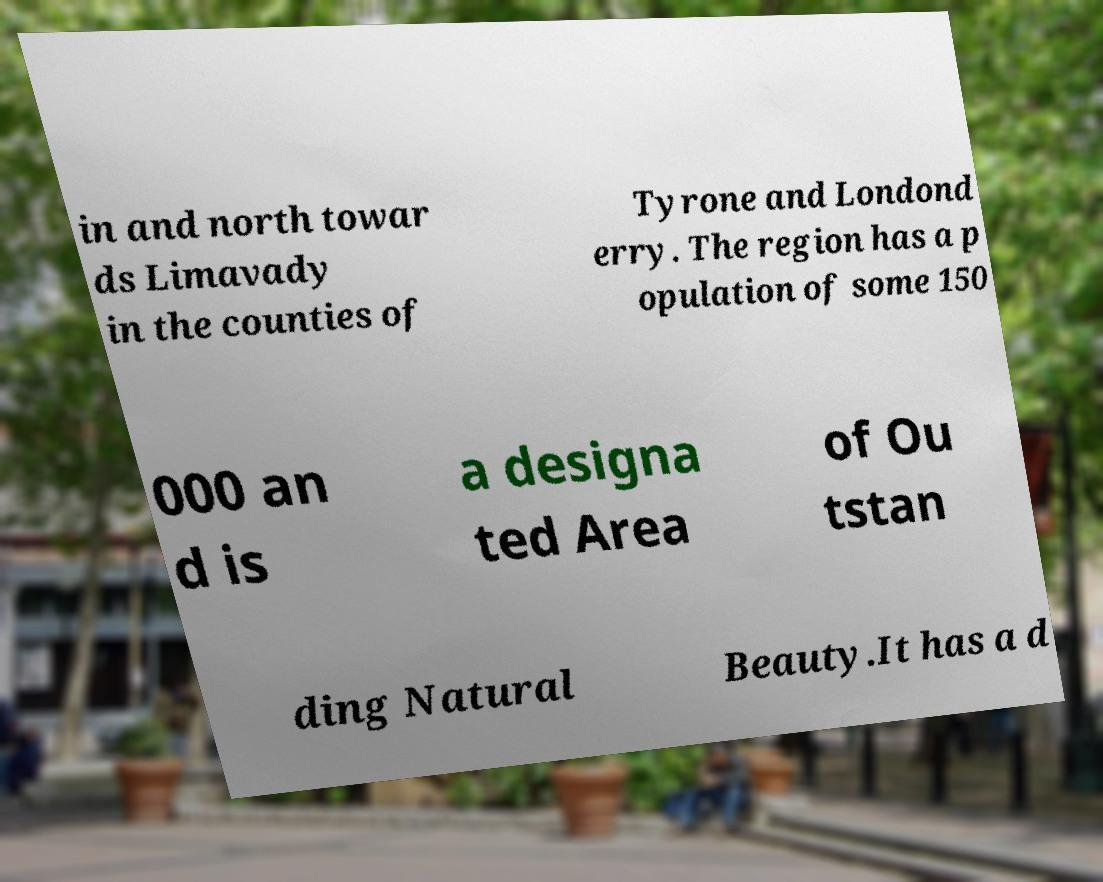There's text embedded in this image that I need extracted. Can you transcribe it verbatim? in and north towar ds Limavady in the counties of Tyrone and Londond erry. The region has a p opulation of some 150 000 an d is a designa ted Area of Ou tstan ding Natural Beauty.It has a d 